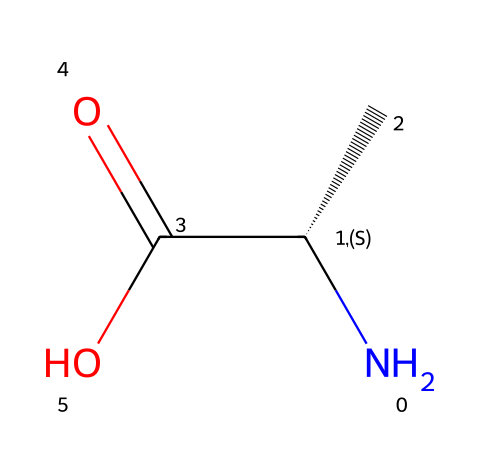What type of compound is represented by this SMILES notation? The SMILES notation shows that this compound contains an amine group (N), a carboxylic acid group (C(=O)O), and an alpha carbon with an attached side chain (C). The presence of both amine and carboxylic acid groups indicates this is an amino acid.
Answer: amino acid How many chiral centers are present in this compound? The notation includes the symbol "@@" next to the carbon attached to the amine group (C[C@@H]), indicating it is a chiral center. There is only one such designation in the SMILES, meaning there is one chiral center.
Answer: one What is the significance of chirality in amino acids? Chirality in amino acids affects how proteins fold and function in biological systems, as only one enantiomer of an amino acid is typically incorporated into proteins. This means that chirality is crucial for the specificity of biochemical interactions.
Answer: biological function What is the molecular formula of this compound? To determine the molecular formula, we count the atoms: one nitrogen (N), three carbons (C), seven hydrogens (H), and two oxygens (O), which leads to the formula C3H7NO2.
Answer: C3H7NO2 Which functional groups are present in this amino acid? The SMILES notation reveals the presence of an amine group (N) and a carboxylic acid group (C(=O)O). These functional groups are characteristic of amino acids and essential for their biological function.
Answer: amine and carboxylic acid What does the “C(C)” in the SMILES indicate? The "C(C)" portion indicates a carbon atom bonded to another carbon, which is branching off, demonstrating that this amino acid has a side chain (also known as an R group). This side chain can vary among different amino acids, affecting their properties.
Answer: side chain 